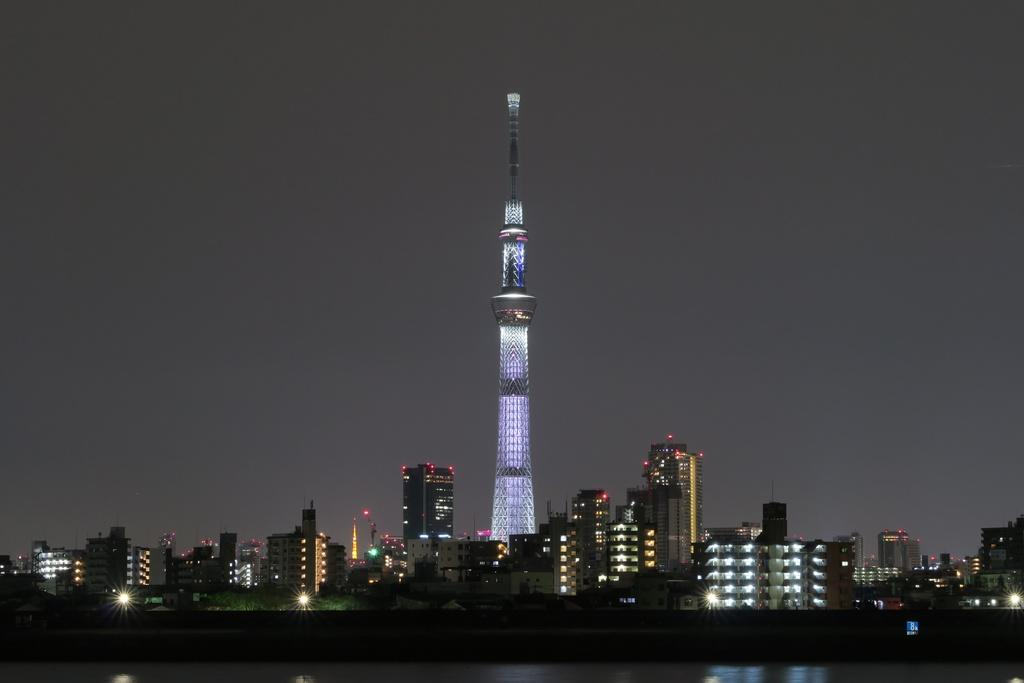What is the main structure in the image? There is a tower in the image. What else can be seen in the image besides the tower? There are many buildings in the image. What is visible at the top of the image? The sky is visible at the top of the image. How many eggs are present in the image? There are no eggs present in the image. What type of care is being provided to the buildings in the image? The image does not show any care being provided to the buildings; it only shows the structures themselves. 